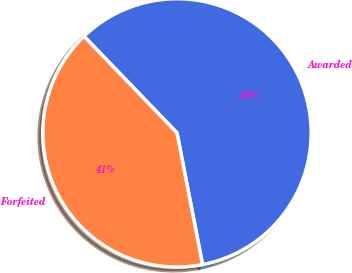Convert chart. <chart><loc_0><loc_0><loc_500><loc_500><pie_chart><fcel>Awarded<fcel>Forfeited<nl><fcel>59.15%<fcel>40.85%<nl></chart> 